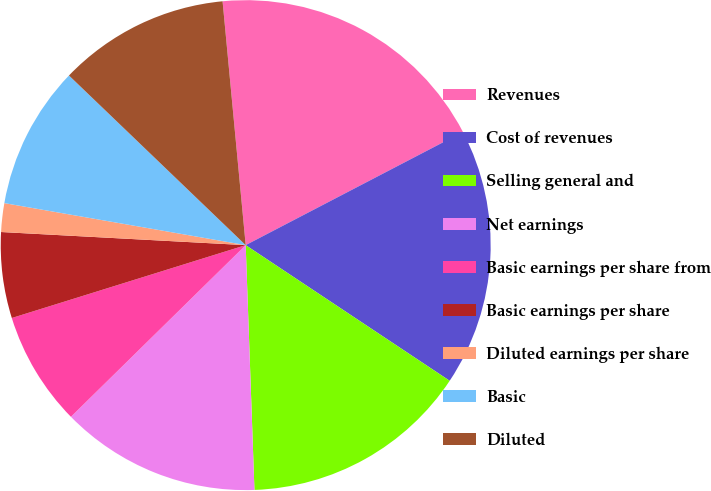Convert chart. <chart><loc_0><loc_0><loc_500><loc_500><pie_chart><fcel>Revenues<fcel>Cost of revenues<fcel>Selling general and<fcel>Net earnings<fcel>Basic earnings per share from<fcel>Basic earnings per share<fcel>Diluted earnings per share<fcel>Basic<fcel>Diluted<nl><fcel>18.86%<fcel>16.98%<fcel>15.09%<fcel>13.21%<fcel>7.55%<fcel>5.66%<fcel>1.89%<fcel>9.43%<fcel>11.32%<nl></chart> 